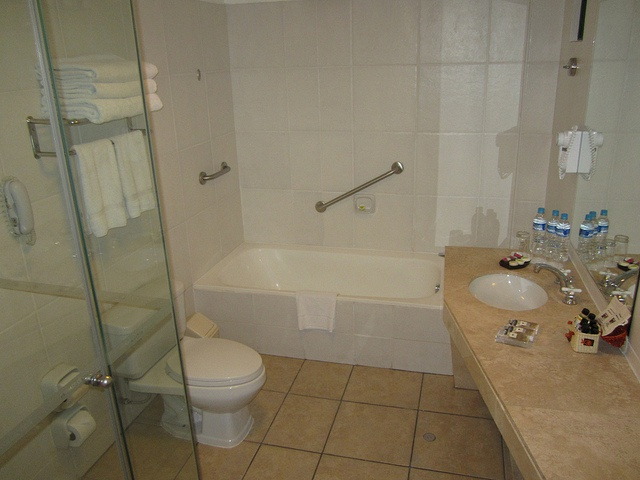Describe the objects in this image and their specific colors. I can see toilet in gray, darkgreen, and darkgray tones, sink in gray and darkgray tones, bottle in gray and darkgray tones, bottle in gray, darkgray, and blue tones, and bottle in gray and darkgray tones in this image. 